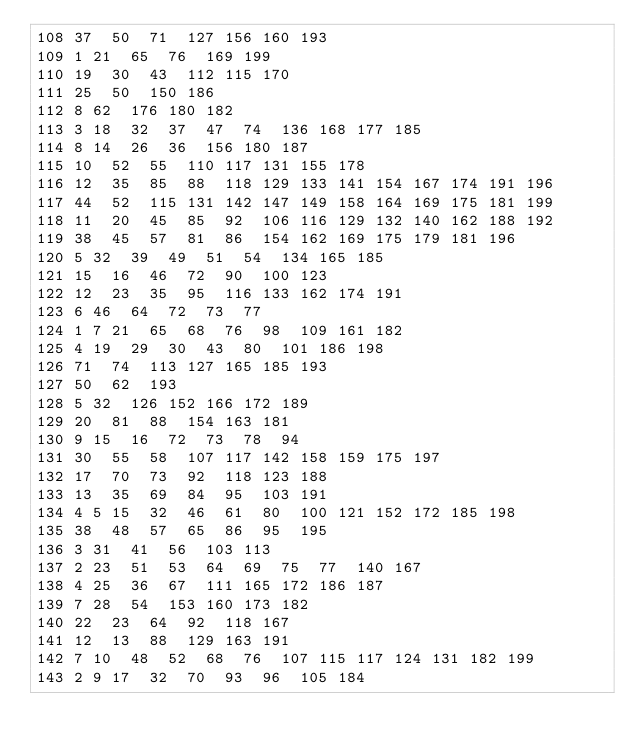<code> <loc_0><loc_0><loc_500><loc_500><_Perl_>108	37	50	71	127	156	160	193
109	1	21	65	76	169	199
110	19	30	43	112	115	170
111	25	50	150	186
112	8	62	176	180	182
113	3	18	32	37	47	74	136	168	177	185
114	8	14	26	36	156	180	187
115	10	52	55	110	117	131	155	178
116	12	35	85	88	118	129	133	141	154	167	174	191	196
117	44	52	115	131	142	147	149	158	164	169	175	181	199
118	11	20	45	85	92	106	116	129	132	140	162	188	192
119	38	45	57	81	86	154	162	169	175	179	181	196
120	5	32	39	49	51	54	134	165	185
121	15	16	46	72	90	100	123
122	12	23	35	95	116	133	162	174	191
123	6	46	64	72	73	77
124	1	7	21	65	68	76	98	109	161	182
125	4	19	29	30	43	80	101	186	198
126	71	74	113	127	165	185	193
127	50	62	193
128	5	32	126	152	166	172	189
129	20	81	88	154	163	181
130	9	15	16	72	73	78	94
131	30	55	58	107	117	142	158	159	175	197
132	17	70	73	92	118	123	188
133	13	35	69	84	95	103	191
134	4	5	15	32	46	61	80	100	121	152	172	185	198
135	38	48	57	65	86	95	195
136	3	31	41	56	103	113
137	2	23	51	53	64	69	75	77	140	167
138	4	25	36	67	111	165	172	186	187
139	7	28	54	153	160	173	182
140	22	23	64	92	118	167
141	12	13	88	129	163	191
142	7	10	48	52	68	76	107	115	117	124	131	182	199
143	2	9	17	32	70	93	96	105	184</code> 